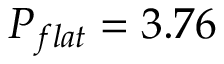Convert formula to latex. <formula><loc_0><loc_0><loc_500><loc_500>P _ { f l a t } = 3 . 7 6</formula> 